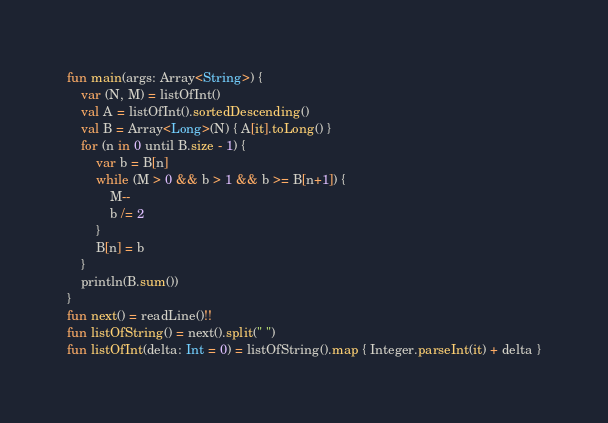<code> <loc_0><loc_0><loc_500><loc_500><_Kotlin_>fun main(args: Array<String>) {
    var (N, M) = listOfInt()
    val A = listOfInt().sortedDescending()
    val B = Array<Long>(N) { A[it].toLong() }
    for (n in 0 until B.size - 1) {
        var b = B[n]
        while (M > 0 && b > 1 && b >= B[n+1]) {
            M--
            b /= 2
        }
        B[n] = b
    }
    println(B.sum())
}
fun next() = readLine()!!
fun listOfString() = next().split(" ")
fun listOfInt(delta: Int = 0) = listOfString().map { Integer.parseInt(it) + delta }</code> 